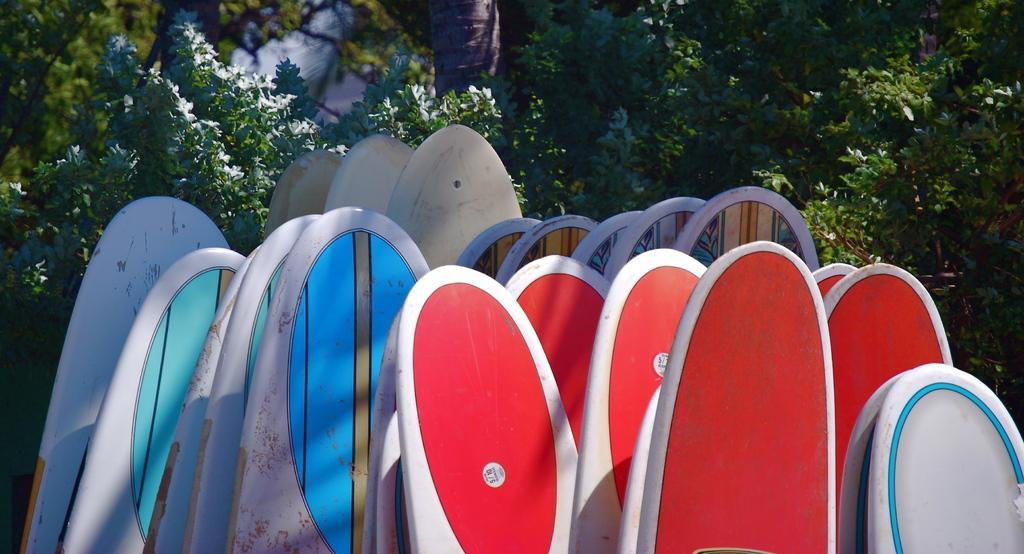Describe this image in one or two sentences. In this picture I can see there are different colors of surfing boards and in the backdrop I can see there are plants and trees. 